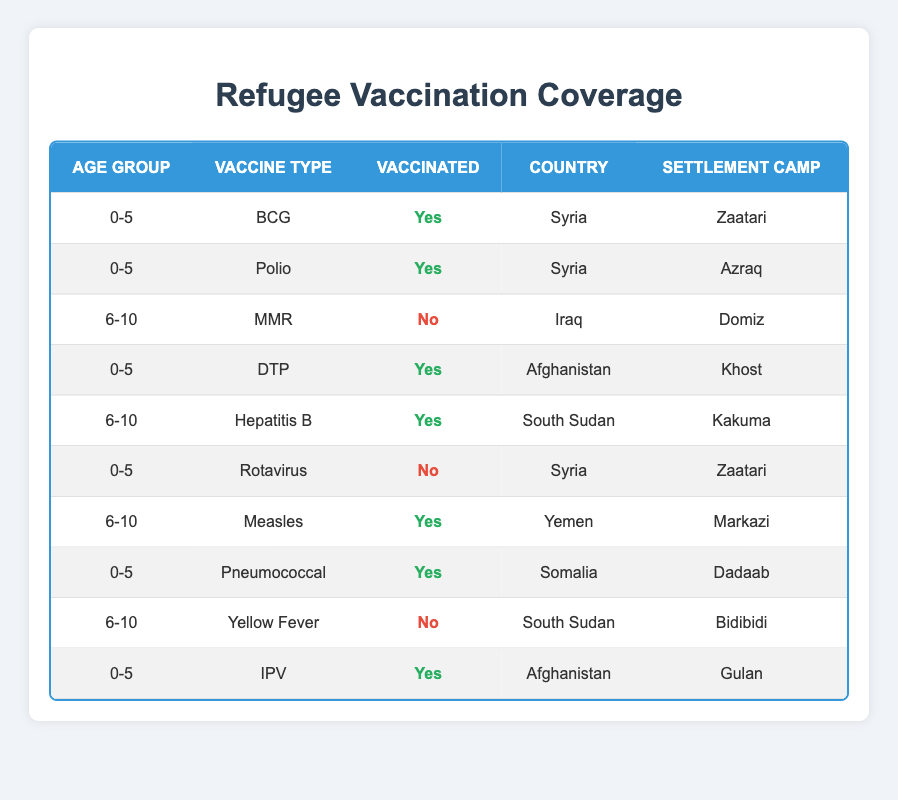What vaccine type had the most vaccinated children in the age group 0-5? In the age group 0-5, we have BCG, Polio, DTP, Pneumococcal, and IPV listed with vaccination statuses. BCG, Polio, DTP, Pneumococcal, and IPV have all children vaccinated, totaling 5 children vaccinated. In this case, no single vaccine type stands out as having the most vaccinated children because all of them have equal numbers.
Answer: None How many children in the age group 6-10 were vaccinated? The age group 6-10 includes MMR, Hepatitis B, Measles, and Yellow Fever. Out of these, only Hepatitis B and Measles were vaccinated (2 children). MMR and Yellow Fever had no vaccinated children. Summing that gives a total of 2 vaccinated children.
Answer: 2 Which country has the highest number of vaccinated children in the refugee dataset? By examining the table, the total vaccinated children per country are: Syria (3), Afghanistan (2), Somalia (1), Yemen (1), and South Sudan (1). Thus, Syria has the highest number of vaccinated children, with 3.
Answer: Syria Are there any refugees in the table who were not vaccinated for MMR? Yes, according to the data presented, the refugee from Iraq in the age group 6-10 who received MMR was not vaccinated. This means there is at least one refugee who did not receive this vaccine, confirming the statement as true.
Answer: Yes What percentage of children aged 0-5 are vaccinated? In the 0-5 age group, there are 5 children (BCG, Polio, DTP, Pneumococcal, IPV). Out of these, 4 children are vaccinated. To calculate the percentage of vaccinated kids, we use the formula: (number of vaccinated / total number of children) * 100 = (4 / 5) * 100 = 80%.
Answer: 80% How many different vaccine types were given to children aged 6-10? The age group 6-10 lists four vaccine types: MMR, Hepatitis B, Measles, and Yellow Fever. Even though some children were vaccinated for those vaccines, the number of different vaccine types remains the same regardless of vaccination status. Therefore, we conclude there are 4 distinct vaccine types.
Answer: 4 Is there any vaccine type for the age group 6-10 that had no children vaccinated? Yes, MMR and Yellow Fever had no vaccinated children in the age group 6-10. According to the table, MMR records a "No" under Vaccinated, meaning no child received this vaccine, and Yellow Fever also shows "No". So this statement is assessed as true.
Answer: Yes Which settlement camp has the most vaccinated children? From the data, we can list the vaccinated children by settlement camp: Zaatari (2), Azraq (1), Khost (1), Kakuma (1), Markazi (1), Dadaab (1), and Gulan (1). Zaatari has 2 vaccinated children, making it the settlement camp with the highest count of vaccinated children.
Answer: Zaatari 